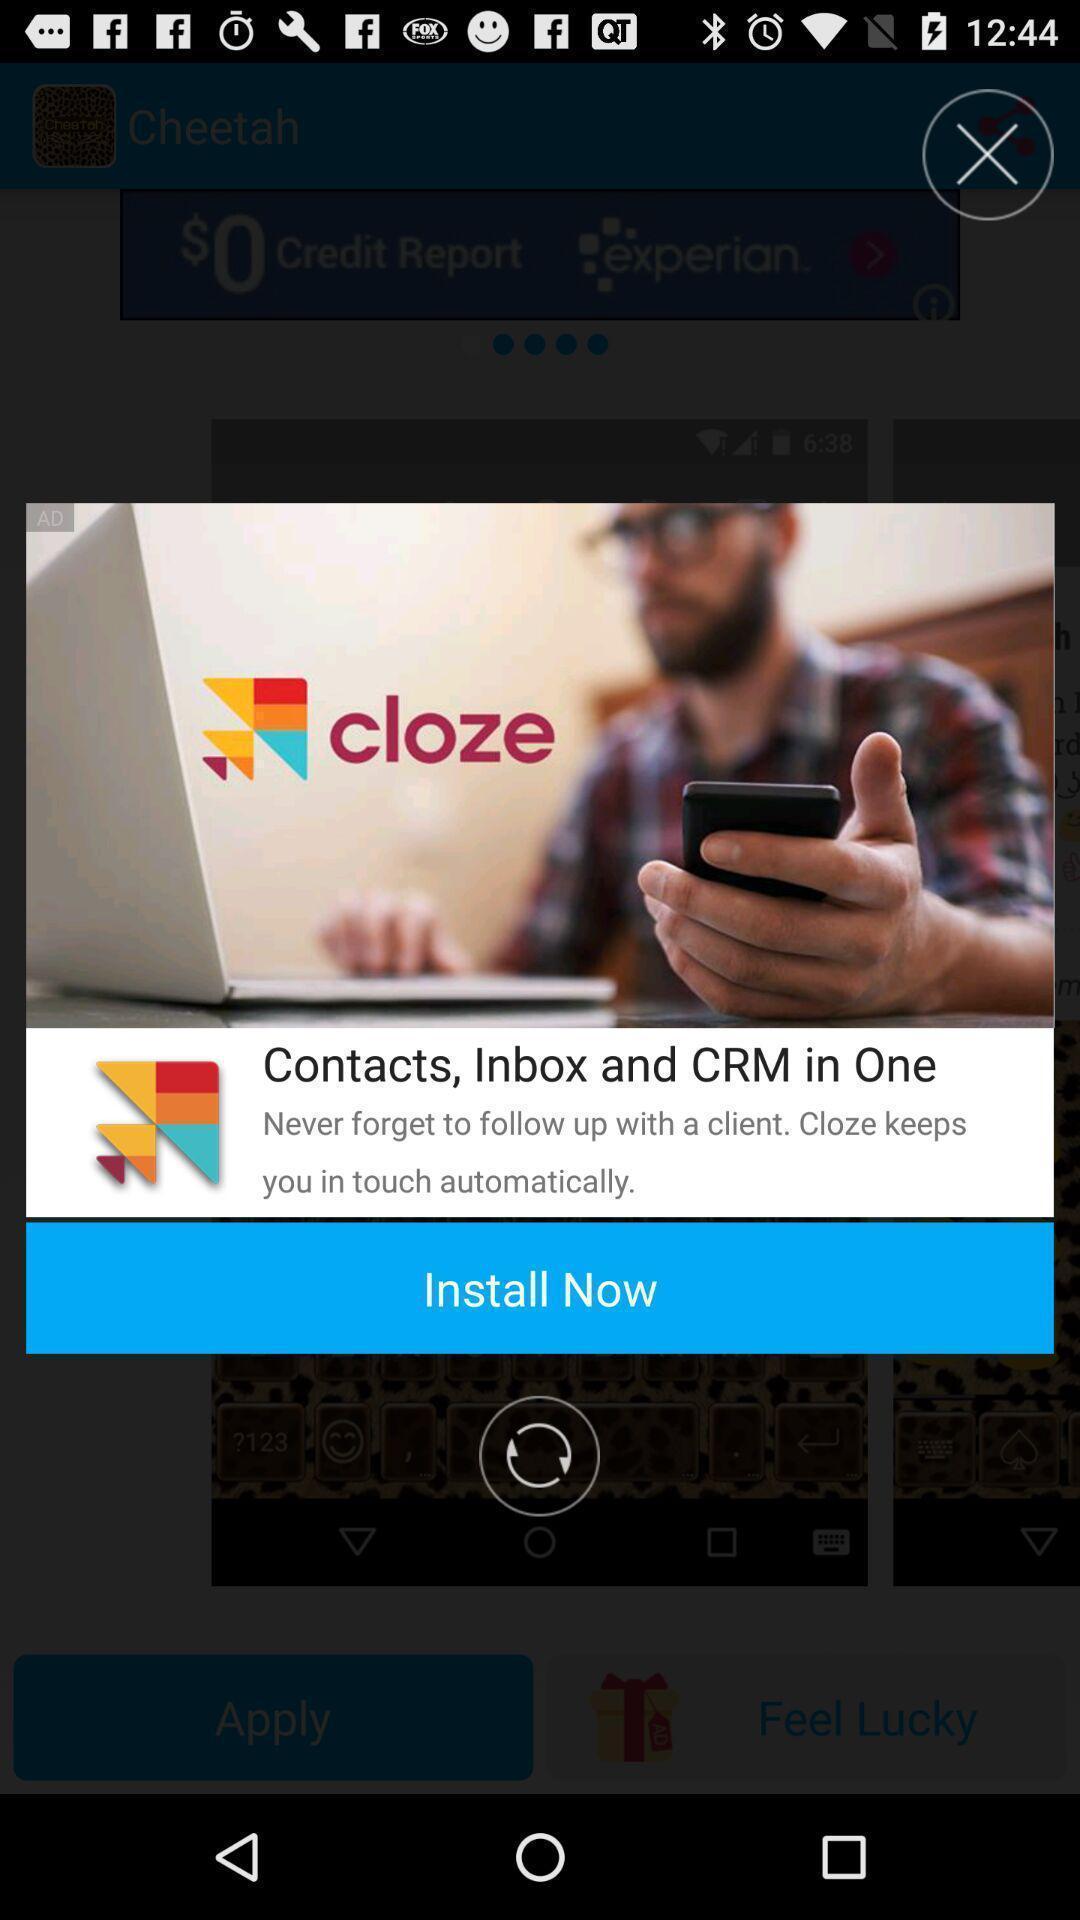Describe this image in words. Pop-up shows installation details. 